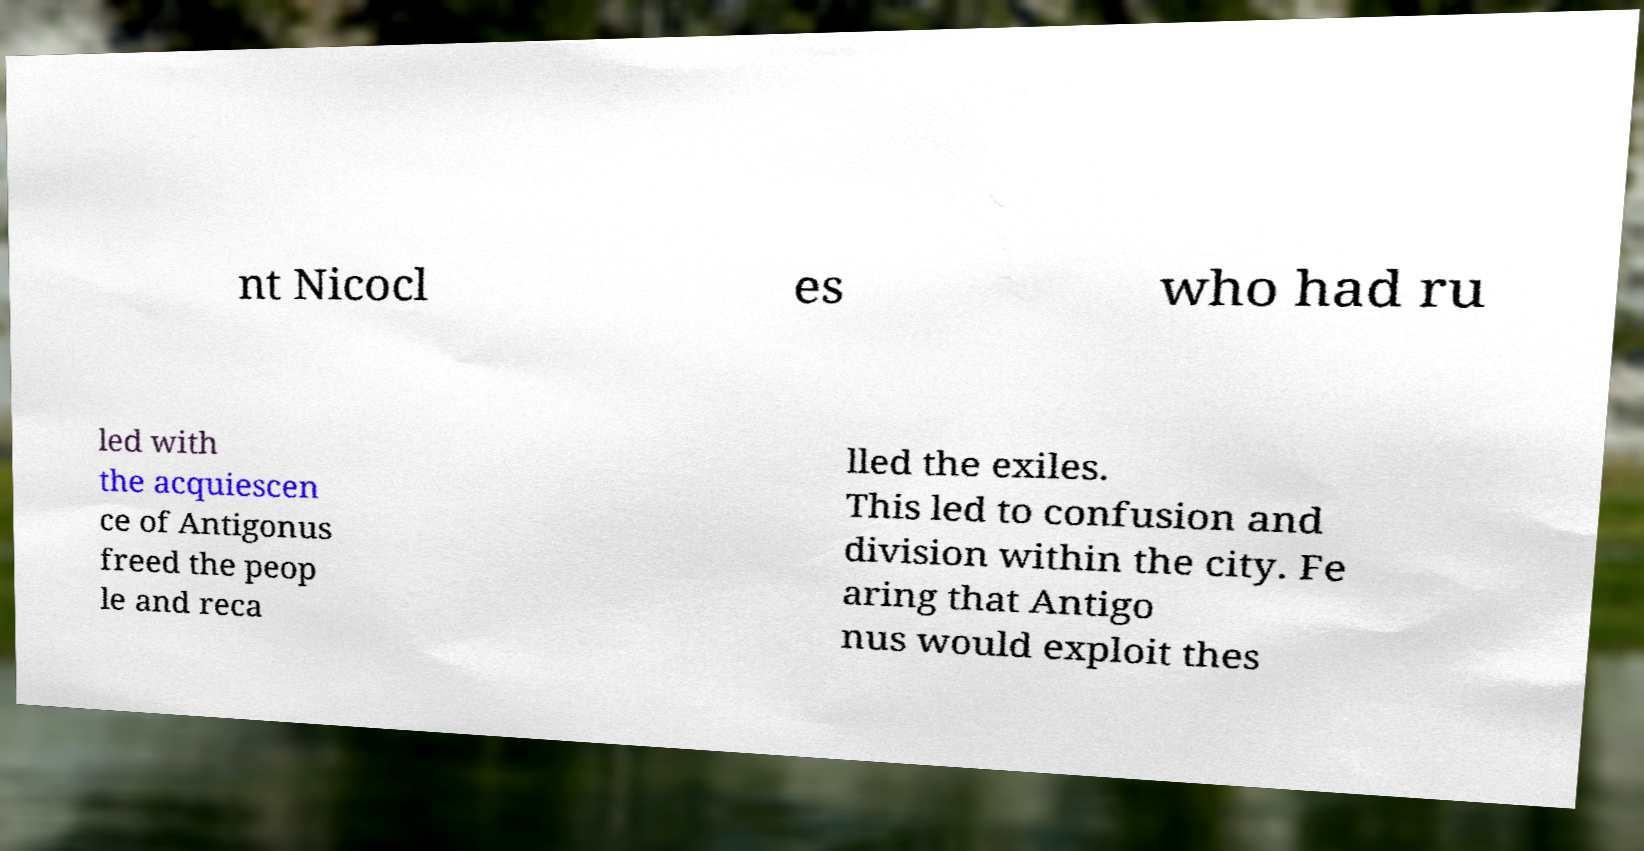There's text embedded in this image that I need extracted. Can you transcribe it verbatim? nt Nicocl es who had ru led with the acquiescen ce of Antigonus freed the peop le and reca lled the exiles. This led to confusion and division within the city. Fe aring that Antigo nus would exploit thes 